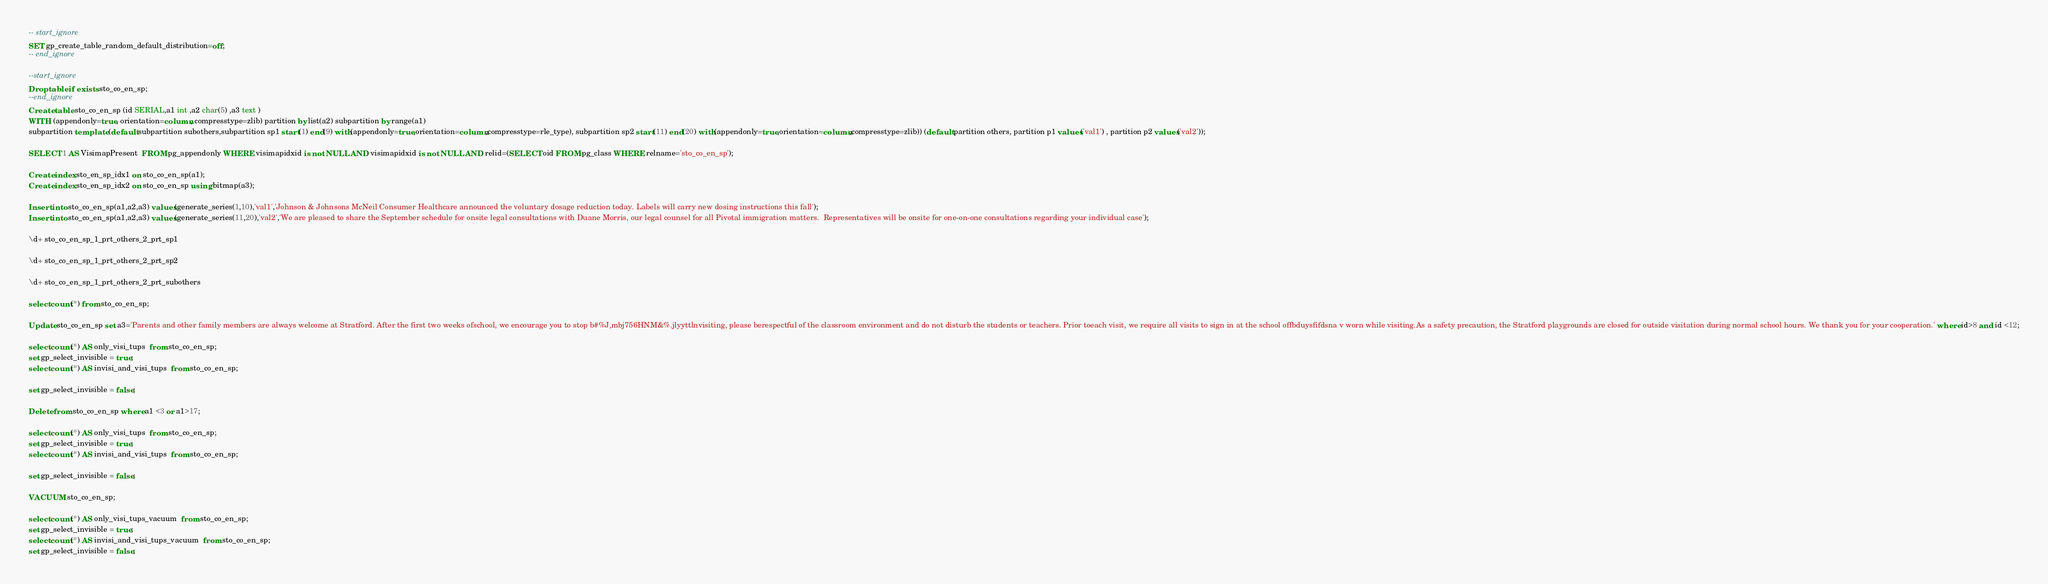<code> <loc_0><loc_0><loc_500><loc_500><_SQL_>-- start_ignore
SET gp_create_table_random_default_distribution=off;
-- end_ignore

--start_ignore
Drop table if exists sto_co_en_sp;
--end_ignore
Create table sto_co_en_sp (id SERIAL,a1 int ,a2 char(5) ,a3 text ) 
WITH (appendonly=true, orientation=column, compresstype=zlib) partition by list(a2) subpartition by range(a1) 
subpartition template (default subpartition subothers,subpartition sp1 start(1) end(9) with(appendonly=true,orientation=column,compresstype=rle_type), subpartition sp2 start(11) end(20) with(appendonly=true,orientation=column,compresstype=zlib)) (default partition others, partition p1 values('val1') , partition p2 values('val2'));

SELECT 1 AS VisimapPresent  FROM pg_appendonly WHERE visimapidxid is not NULL AND visimapidxid is not NULL AND relid=(SELECT oid FROM pg_class WHERE relname='sto_co_en_sp');

Create index sto_en_sp_idx1 on sto_co_en_sp(a1);
Create index sto_en_sp_idx2 on sto_co_en_sp using bitmap(a3);

Insert into sto_co_en_sp(a1,a2,a3) values(generate_series(1,10),'val1','Johnson & Johnsons McNeil Consumer Healthcare announced the voluntary dosage reduction today. Labels will carry new dosing instructions this fall');
Insert into sto_co_en_sp(a1,a2,a3) values(generate_series(11,20),'val2','We are pleased to share the September schedule for onsite legal consultations with Duane Morris, our legal counsel for all Pivotal immigration matters.  Representatives will be onsite for one-on-one consultations regarding your individual case');

\d+ sto_co_en_sp_1_prt_others_2_prt_sp1

\d+ sto_co_en_sp_1_prt_others_2_prt_sp2

\d+ sto_co_en_sp_1_prt_others_2_prt_subothers

select count(*) from sto_co_en_sp;

Update sto_co_en_sp set a3='Parents and other family members are always welcome at Stratford. After the first two weeks ofschool, we encourage you to stop b#%J,mbj756HNM&%.jlyyttlnvisiting, please berespectful of the classroom environment and do not disturb the students or teachers. Prior toeach visit, we require all visits to sign in at the school offbduysfifdsna v worn while visiting.As a safety precaution, the Stratford playgrounds are closed for outside visitation during normal school hours. We thank you for your cooperation.' where id>8 and id <12;

select count(*) AS only_visi_tups  from sto_co_en_sp;
set gp_select_invisible = true;
select count(*) AS invisi_and_visi_tups  from sto_co_en_sp;

set gp_select_invisible = false;

Delete from sto_co_en_sp where a1 <3 or a1>17;

select count(*) AS only_visi_tups  from sto_co_en_sp;
set gp_select_invisible = true;
select count(*) AS invisi_and_visi_tups  from sto_co_en_sp;

set gp_select_invisible = false;

VACUUM sto_co_en_sp;

select count(*) AS only_visi_tups_vacuum  from sto_co_en_sp;
set gp_select_invisible = true;
select count(*) AS invisi_and_visi_tups_vacuum  from sto_co_en_sp;
set gp_select_invisible = false;


</code> 